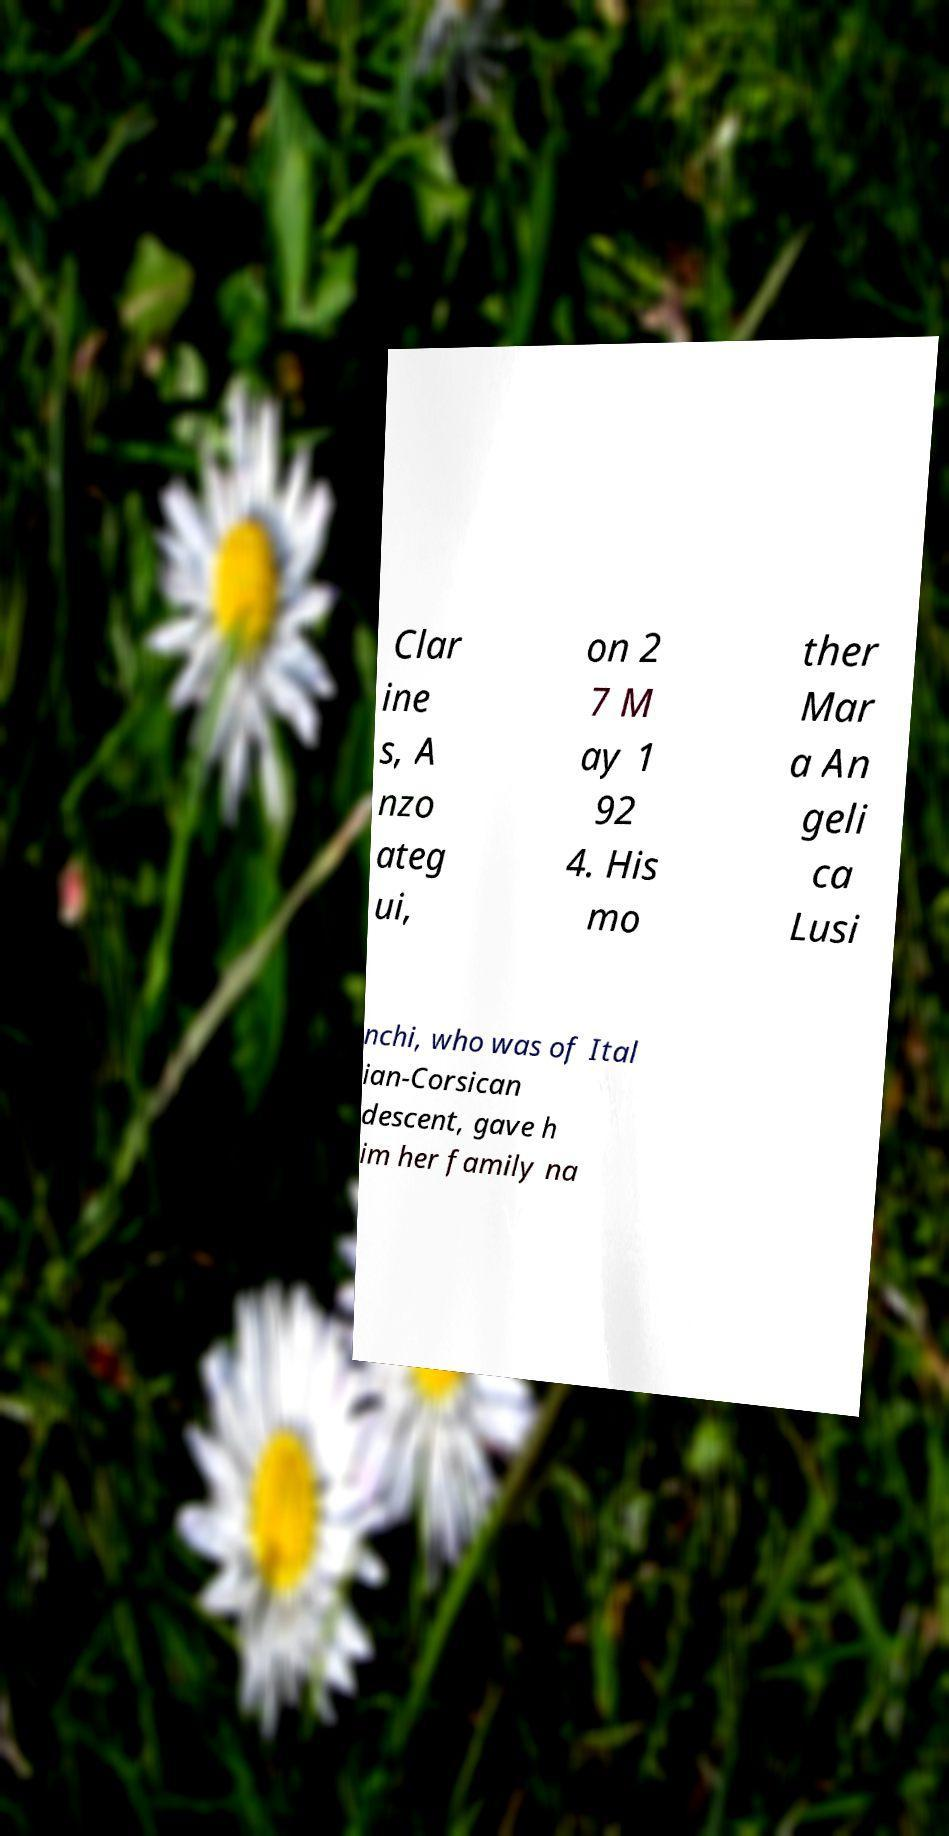What messages or text are displayed in this image? I need them in a readable, typed format. Clar ine s, A nzo ateg ui, on 2 7 M ay 1 92 4. His mo ther Mar a An geli ca Lusi nchi, who was of Ital ian-Corsican descent, gave h im her family na 